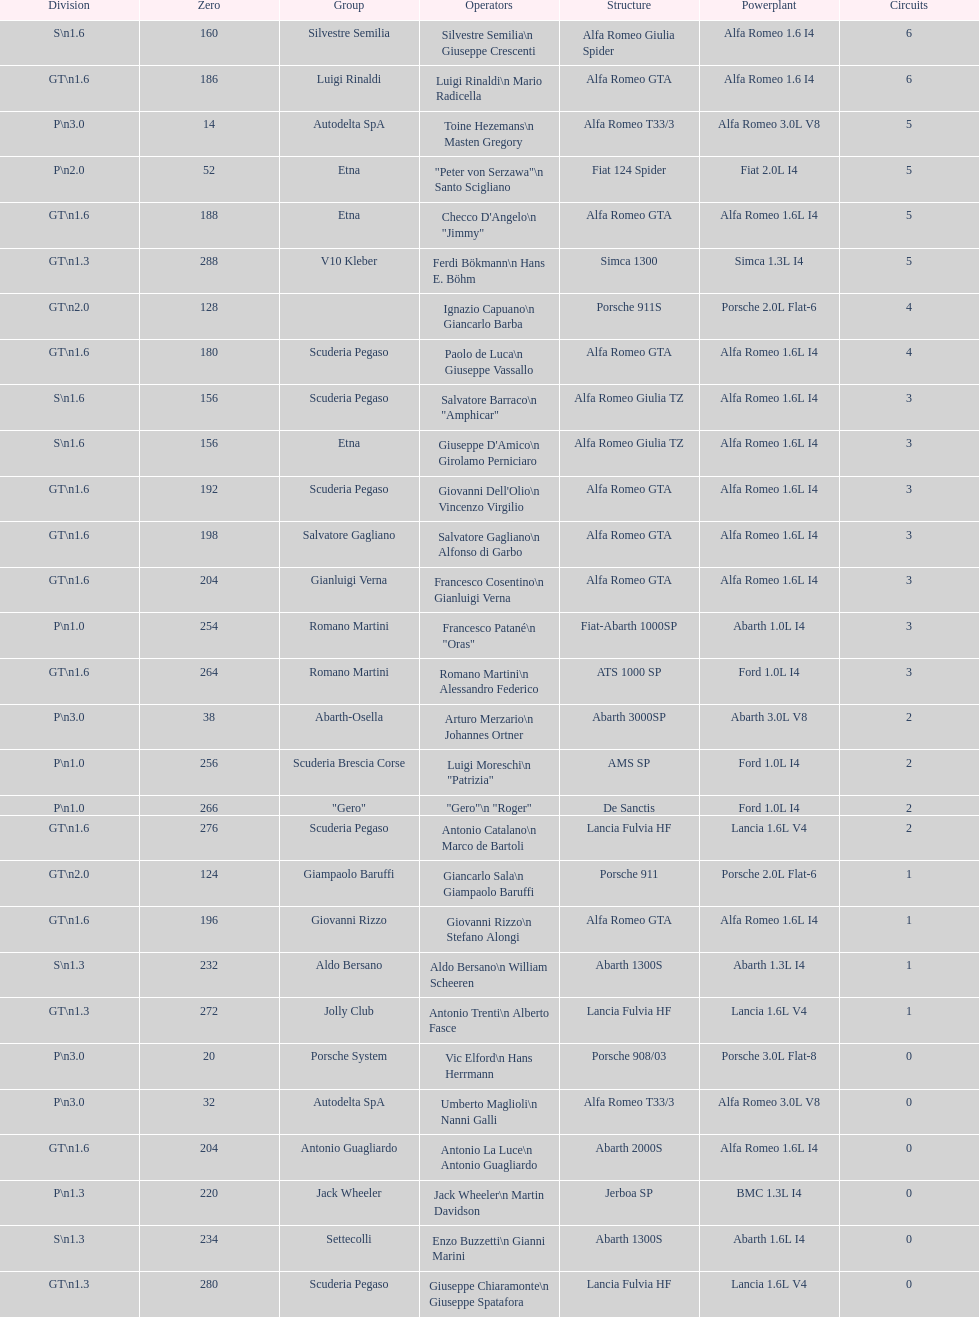Which chassis is in the middle of simca 1300 and alfa romeo gta? Porsche 911S. 